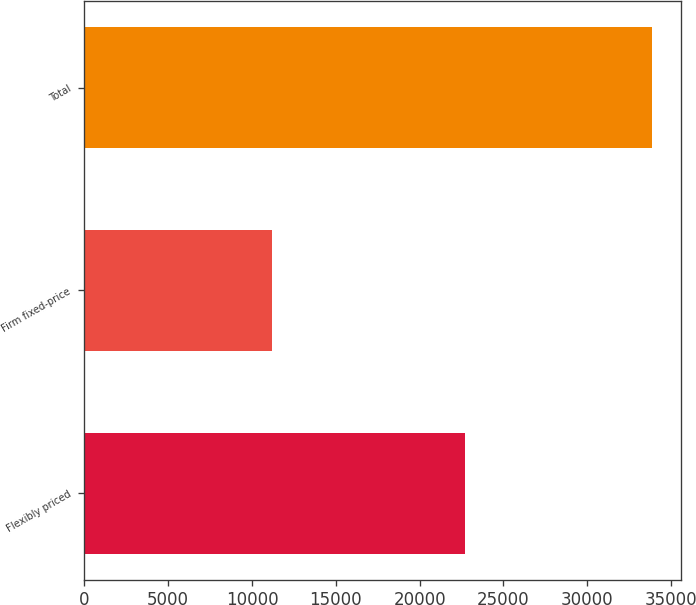<chart> <loc_0><loc_0><loc_500><loc_500><bar_chart><fcel>Flexibly priced<fcel>Firm fixed-price<fcel>Total<nl><fcel>22718<fcel>11169<fcel>33887<nl></chart> 